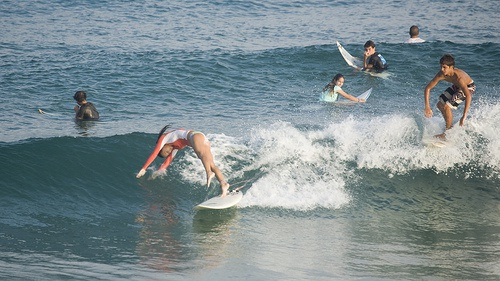Describe the objects in this image and their specific colors. I can see people in gray, tan, lightgray, and darkgray tones, people in gray, tan, and black tones, people in gray, darkgray, beige, and tan tones, surfboard in gray, darkgray, and lightgray tones, and surfboard in gray, lightgray, darkgray, and beige tones in this image. 